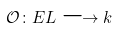<formula> <loc_0><loc_0><loc_500><loc_500>\mathcal { O } \colon E L \longrightarrow k</formula> 